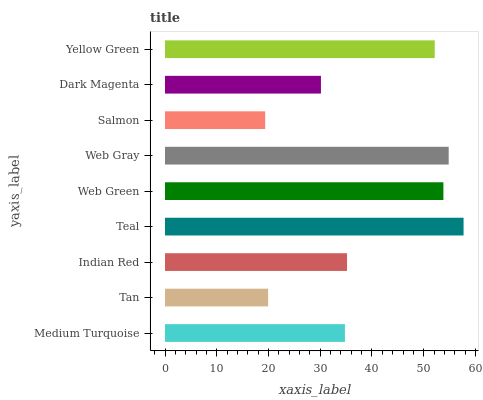Is Salmon the minimum?
Answer yes or no. Yes. Is Teal the maximum?
Answer yes or no. Yes. Is Tan the minimum?
Answer yes or no. No. Is Tan the maximum?
Answer yes or no. No. Is Medium Turquoise greater than Tan?
Answer yes or no. Yes. Is Tan less than Medium Turquoise?
Answer yes or no. Yes. Is Tan greater than Medium Turquoise?
Answer yes or no. No. Is Medium Turquoise less than Tan?
Answer yes or no. No. Is Indian Red the high median?
Answer yes or no. Yes. Is Indian Red the low median?
Answer yes or no. Yes. Is Web Gray the high median?
Answer yes or no. No. Is Tan the low median?
Answer yes or no. No. 